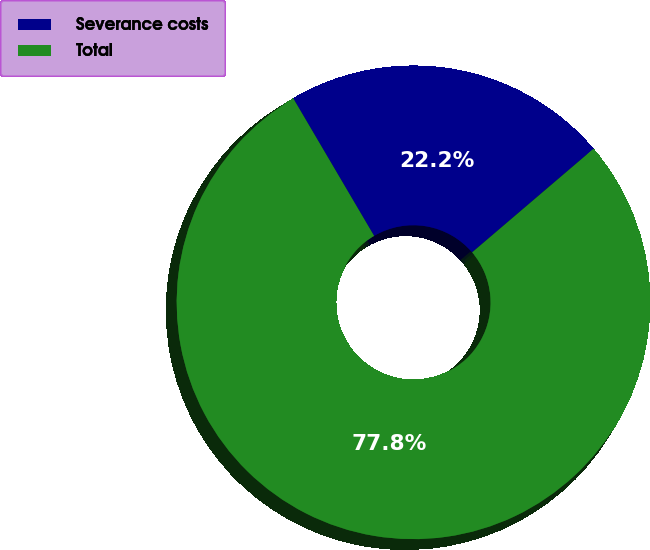<chart> <loc_0><loc_0><loc_500><loc_500><pie_chart><fcel>Severance costs<fcel>Total<nl><fcel>22.22%<fcel>77.78%<nl></chart> 